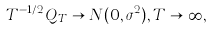<formula> <loc_0><loc_0><loc_500><loc_500>T ^ { - 1 / 2 } Q _ { T } \rightarrow N ( 0 , \sigma ^ { 2 } ) , T \rightarrow \infty ,</formula> 